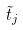<formula> <loc_0><loc_0><loc_500><loc_500>\tilde { t } _ { j }</formula> 